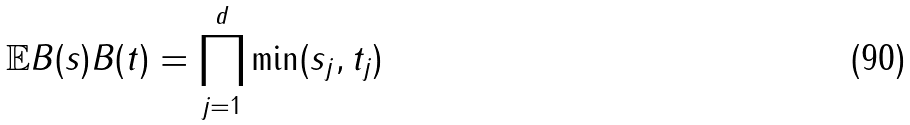Convert formula to latex. <formula><loc_0><loc_0><loc_500><loc_500>\mathbb { E } B ( s ) B ( t ) = \prod _ { j = 1 } ^ { d } \min ( s _ { j } , t _ { j } )</formula> 